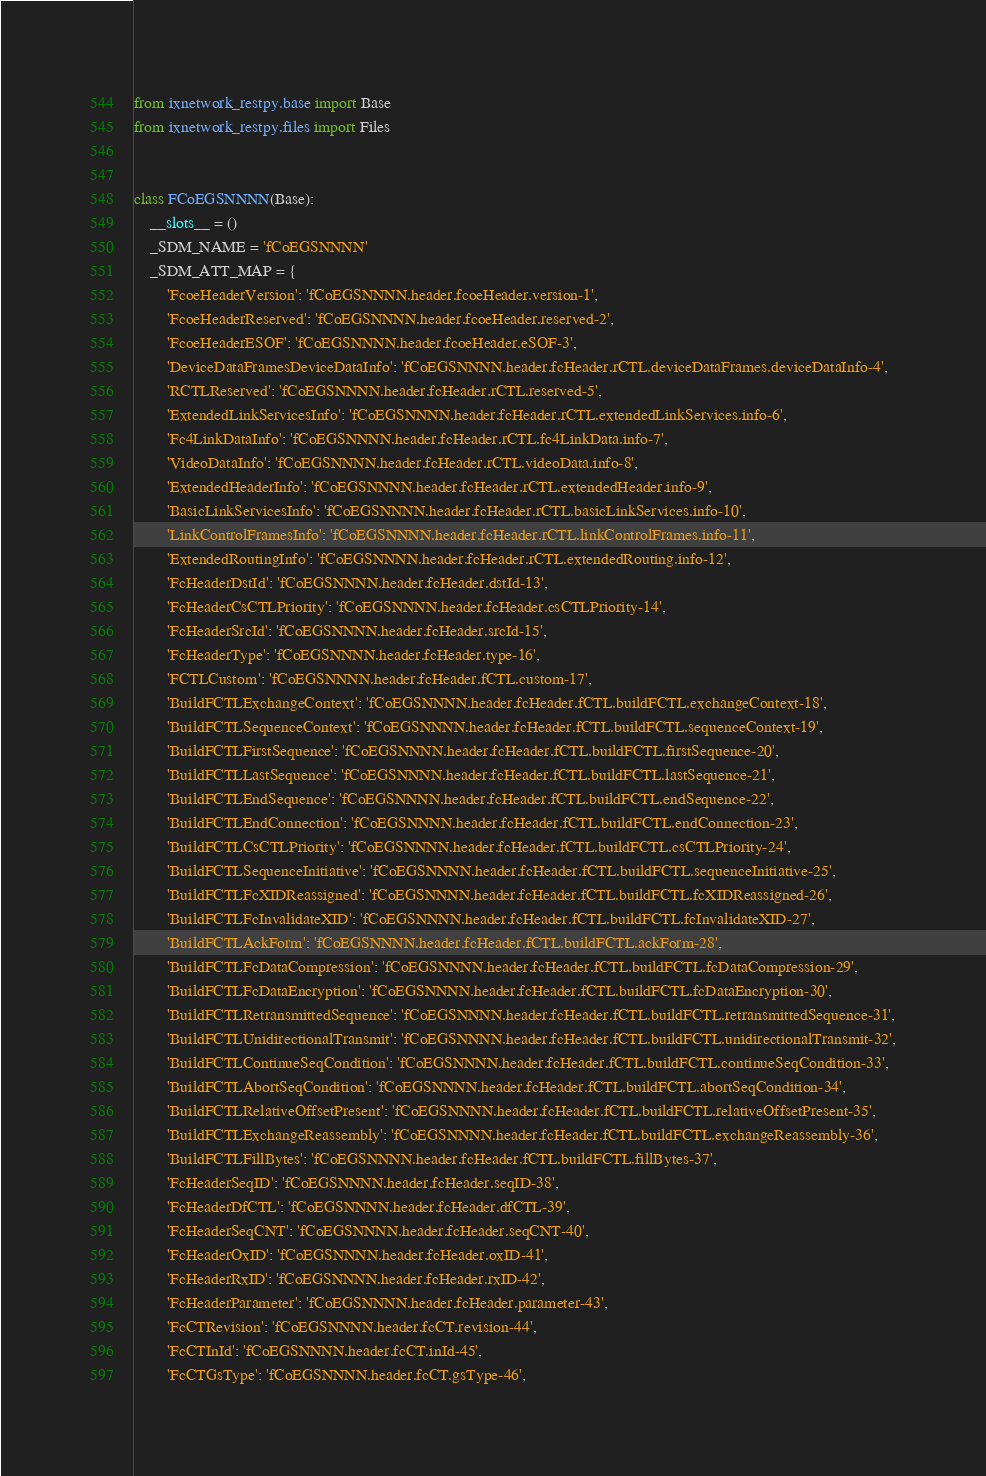Convert code to text. <code><loc_0><loc_0><loc_500><loc_500><_Python_>from ixnetwork_restpy.base import Base
from ixnetwork_restpy.files import Files


class FCoEGSNNNN(Base):
    __slots__ = ()
    _SDM_NAME = 'fCoEGSNNNN'
    _SDM_ATT_MAP = {
        'FcoeHeaderVersion': 'fCoEGSNNNN.header.fcoeHeader.version-1',
        'FcoeHeaderReserved': 'fCoEGSNNNN.header.fcoeHeader.reserved-2',
        'FcoeHeaderESOF': 'fCoEGSNNNN.header.fcoeHeader.eSOF-3',
        'DeviceDataFramesDeviceDataInfo': 'fCoEGSNNNN.header.fcHeader.rCTL.deviceDataFrames.deviceDataInfo-4',
        'RCTLReserved': 'fCoEGSNNNN.header.fcHeader.rCTL.reserved-5',
        'ExtendedLinkServicesInfo': 'fCoEGSNNNN.header.fcHeader.rCTL.extendedLinkServices.info-6',
        'Fc4LinkDataInfo': 'fCoEGSNNNN.header.fcHeader.rCTL.fc4LinkData.info-7',
        'VideoDataInfo': 'fCoEGSNNNN.header.fcHeader.rCTL.videoData.info-8',
        'ExtendedHeaderInfo': 'fCoEGSNNNN.header.fcHeader.rCTL.extendedHeader.info-9',
        'BasicLinkServicesInfo': 'fCoEGSNNNN.header.fcHeader.rCTL.basicLinkServices.info-10',
        'LinkControlFramesInfo': 'fCoEGSNNNN.header.fcHeader.rCTL.linkControlFrames.info-11',
        'ExtendedRoutingInfo': 'fCoEGSNNNN.header.fcHeader.rCTL.extendedRouting.info-12',
        'FcHeaderDstId': 'fCoEGSNNNN.header.fcHeader.dstId-13',
        'FcHeaderCsCTLPriority': 'fCoEGSNNNN.header.fcHeader.csCTLPriority-14',
        'FcHeaderSrcId': 'fCoEGSNNNN.header.fcHeader.srcId-15',
        'FcHeaderType': 'fCoEGSNNNN.header.fcHeader.type-16',
        'FCTLCustom': 'fCoEGSNNNN.header.fcHeader.fCTL.custom-17',
        'BuildFCTLExchangeContext': 'fCoEGSNNNN.header.fcHeader.fCTL.buildFCTL.exchangeContext-18',
        'BuildFCTLSequenceContext': 'fCoEGSNNNN.header.fcHeader.fCTL.buildFCTL.sequenceContext-19',
        'BuildFCTLFirstSequence': 'fCoEGSNNNN.header.fcHeader.fCTL.buildFCTL.firstSequence-20',
        'BuildFCTLLastSequence': 'fCoEGSNNNN.header.fcHeader.fCTL.buildFCTL.lastSequence-21',
        'BuildFCTLEndSequence': 'fCoEGSNNNN.header.fcHeader.fCTL.buildFCTL.endSequence-22',
        'BuildFCTLEndConnection': 'fCoEGSNNNN.header.fcHeader.fCTL.buildFCTL.endConnection-23',
        'BuildFCTLCsCTLPriority': 'fCoEGSNNNN.header.fcHeader.fCTL.buildFCTL.csCTLPriority-24',
        'BuildFCTLSequenceInitiative': 'fCoEGSNNNN.header.fcHeader.fCTL.buildFCTL.sequenceInitiative-25',
        'BuildFCTLFcXIDReassigned': 'fCoEGSNNNN.header.fcHeader.fCTL.buildFCTL.fcXIDReassigned-26',
        'BuildFCTLFcInvalidateXID': 'fCoEGSNNNN.header.fcHeader.fCTL.buildFCTL.fcInvalidateXID-27',
        'BuildFCTLAckForm': 'fCoEGSNNNN.header.fcHeader.fCTL.buildFCTL.ackForm-28',
        'BuildFCTLFcDataCompression': 'fCoEGSNNNN.header.fcHeader.fCTL.buildFCTL.fcDataCompression-29',
        'BuildFCTLFcDataEncryption': 'fCoEGSNNNN.header.fcHeader.fCTL.buildFCTL.fcDataEncryption-30',
        'BuildFCTLRetransmittedSequence': 'fCoEGSNNNN.header.fcHeader.fCTL.buildFCTL.retransmittedSequence-31',
        'BuildFCTLUnidirectionalTransmit': 'fCoEGSNNNN.header.fcHeader.fCTL.buildFCTL.unidirectionalTransmit-32',
        'BuildFCTLContinueSeqCondition': 'fCoEGSNNNN.header.fcHeader.fCTL.buildFCTL.continueSeqCondition-33',
        'BuildFCTLAbortSeqCondition': 'fCoEGSNNNN.header.fcHeader.fCTL.buildFCTL.abortSeqCondition-34',
        'BuildFCTLRelativeOffsetPresent': 'fCoEGSNNNN.header.fcHeader.fCTL.buildFCTL.relativeOffsetPresent-35',
        'BuildFCTLExchangeReassembly': 'fCoEGSNNNN.header.fcHeader.fCTL.buildFCTL.exchangeReassembly-36',
        'BuildFCTLFillBytes': 'fCoEGSNNNN.header.fcHeader.fCTL.buildFCTL.fillBytes-37',
        'FcHeaderSeqID': 'fCoEGSNNNN.header.fcHeader.seqID-38',
        'FcHeaderDfCTL': 'fCoEGSNNNN.header.fcHeader.dfCTL-39',
        'FcHeaderSeqCNT': 'fCoEGSNNNN.header.fcHeader.seqCNT-40',
        'FcHeaderOxID': 'fCoEGSNNNN.header.fcHeader.oxID-41',
        'FcHeaderRxID': 'fCoEGSNNNN.header.fcHeader.rxID-42',
        'FcHeaderParameter': 'fCoEGSNNNN.header.fcHeader.parameter-43',
        'FcCTRevision': 'fCoEGSNNNN.header.fcCT.revision-44',
        'FcCTInId': 'fCoEGSNNNN.header.fcCT.inId-45',
        'FcCTGsType': 'fCoEGSNNNN.header.fcCT.gsType-46',</code> 